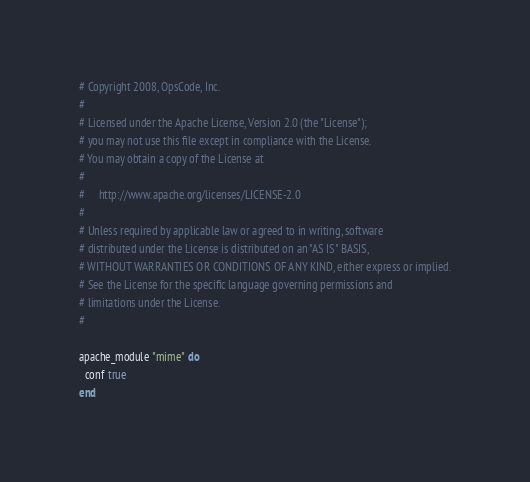Convert code to text. <code><loc_0><loc_0><loc_500><loc_500><_Ruby_># Copyright 2008, OpsCode, Inc.
#
# Licensed under the Apache License, Version 2.0 (the "License");
# you may not use this file except in compliance with the License.
# You may obtain a copy of the License at
# 
#     http://www.apache.org/licenses/LICENSE-2.0
# 
# Unless required by applicable law or agreed to in writing, software
# distributed under the License is distributed on an "AS IS" BASIS,
# WITHOUT WARRANTIES OR CONDITIONS OF ANY KIND, either express or implied.
# See the License for the specific language governing permissions and
# limitations under the License.
#

apache_module "mime" do
  conf true
end
</code> 